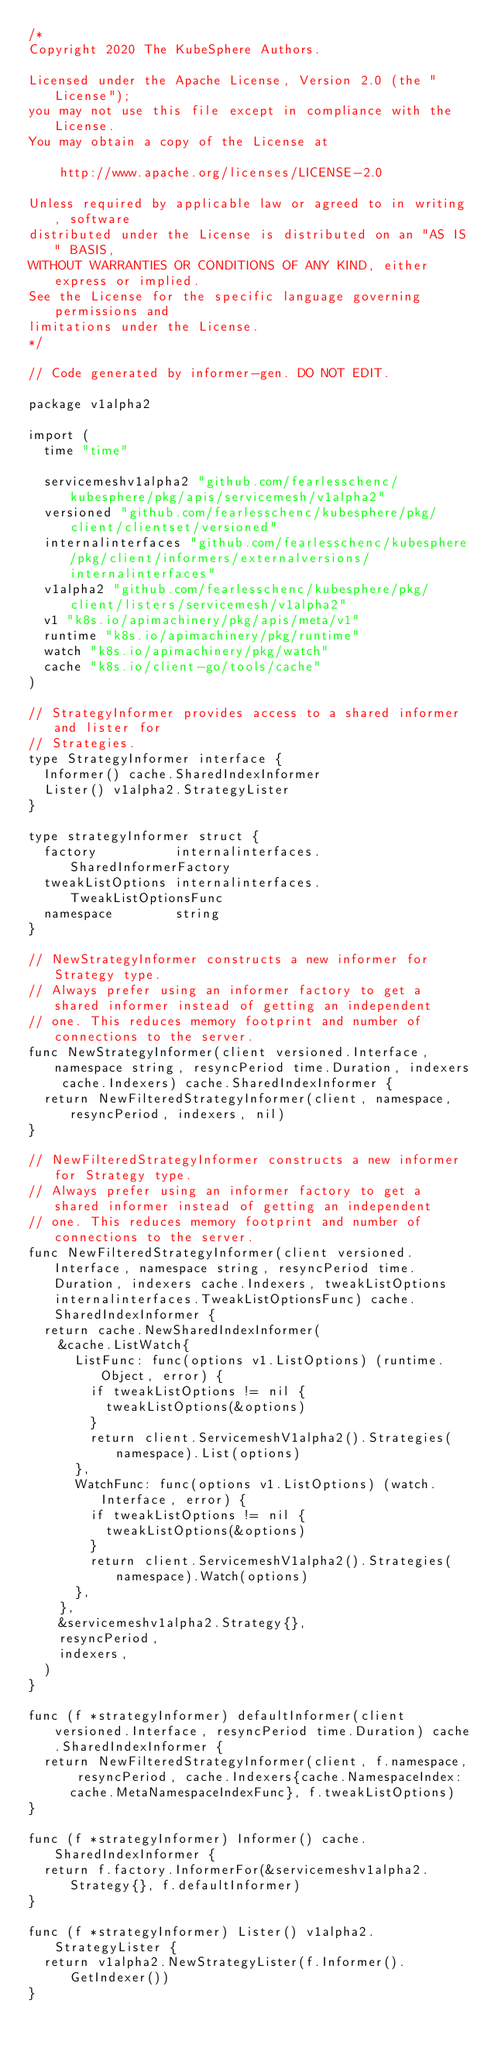<code> <loc_0><loc_0><loc_500><loc_500><_Go_>/*
Copyright 2020 The KubeSphere Authors.

Licensed under the Apache License, Version 2.0 (the "License");
you may not use this file except in compliance with the License.
You may obtain a copy of the License at

    http://www.apache.org/licenses/LICENSE-2.0

Unless required by applicable law or agreed to in writing, software
distributed under the License is distributed on an "AS IS" BASIS,
WITHOUT WARRANTIES OR CONDITIONS OF ANY KIND, either express or implied.
See the License for the specific language governing permissions and
limitations under the License.
*/

// Code generated by informer-gen. DO NOT EDIT.

package v1alpha2

import (
	time "time"

	servicemeshv1alpha2 "github.com/fearlesschenc/kubesphere/pkg/apis/servicemesh/v1alpha2"
	versioned "github.com/fearlesschenc/kubesphere/pkg/client/clientset/versioned"
	internalinterfaces "github.com/fearlesschenc/kubesphere/pkg/client/informers/externalversions/internalinterfaces"
	v1alpha2 "github.com/fearlesschenc/kubesphere/pkg/client/listers/servicemesh/v1alpha2"
	v1 "k8s.io/apimachinery/pkg/apis/meta/v1"
	runtime "k8s.io/apimachinery/pkg/runtime"
	watch "k8s.io/apimachinery/pkg/watch"
	cache "k8s.io/client-go/tools/cache"
)

// StrategyInformer provides access to a shared informer and lister for
// Strategies.
type StrategyInformer interface {
	Informer() cache.SharedIndexInformer
	Lister() v1alpha2.StrategyLister
}

type strategyInformer struct {
	factory          internalinterfaces.SharedInformerFactory
	tweakListOptions internalinterfaces.TweakListOptionsFunc
	namespace        string
}

// NewStrategyInformer constructs a new informer for Strategy type.
// Always prefer using an informer factory to get a shared informer instead of getting an independent
// one. This reduces memory footprint and number of connections to the server.
func NewStrategyInformer(client versioned.Interface, namespace string, resyncPeriod time.Duration, indexers cache.Indexers) cache.SharedIndexInformer {
	return NewFilteredStrategyInformer(client, namespace, resyncPeriod, indexers, nil)
}

// NewFilteredStrategyInformer constructs a new informer for Strategy type.
// Always prefer using an informer factory to get a shared informer instead of getting an independent
// one. This reduces memory footprint and number of connections to the server.
func NewFilteredStrategyInformer(client versioned.Interface, namespace string, resyncPeriod time.Duration, indexers cache.Indexers, tweakListOptions internalinterfaces.TweakListOptionsFunc) cache.SharedIndexInformer {
	return cache.NewSharedIndexInformer(
		&cache.ListWatch{
			ListFunc: func(options v1.ListOptions) (runtime.Object, error) {
				if tweakListOptions != nil {
					tweakListOptions(&options)
				}
				return client.ServicemeshV1alpha2().Strategies(namespace).List(options)
			},
			WatchFunc: func(options v1.ListOptions) (watch.Interface, error) {
				if tweakListOptions != nil {
					tweakListOptions(&options)
				}
				return client.ServicemeshV1alpha2().Strategies(namespace).Watch(options)
			},
		},
		&servicemeshv1alpha2.Strategy{},
		resyncPeriod,
		indexers,
	)
}

func (f *strategyInformer) defaultInformer(client versioned.Interface, resyncPeriod time.Duration) cache.SharedIndexInformer {
	return NewFilteredStrategyInformer(client, f.namespace, resyncPeriod, cache.Indexers{cache.NamespaceIndex: cache.MetaNamespaceIndexFunc}, f.tweakListOptions)
}

func (f *strategyInformer) Informer() cache.SharedIndexInformer {
	return f.factory.InformerFor(&servicemeshv1alpha2.Strategy{}, f.defaultInformer)
}

func (f *strategyInformer) Lister() v1alpha2.StrategyLister {
	return v1alpha2.NewStrategyLister(f.Informer().GetIndexer())
}
</code> 